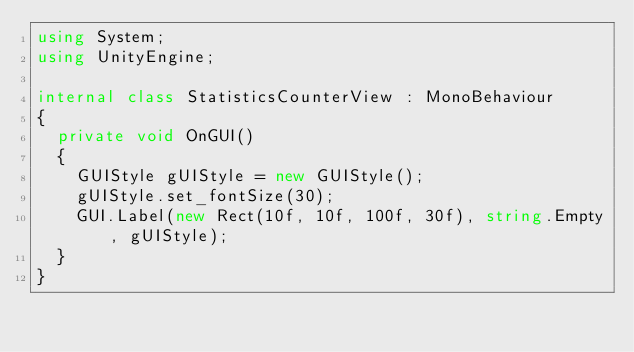<code> <loc_0><loc_0><loc_500><loc_500><_C#_>using System;
using UnityEngine;

internal class StatisticsCounterView : MonoBehaviour
{
	private void OnGUI()
	{
		GUIStyle gUIStyle = new GUIStyle();
		gUIStyle.set_fontSize(30);
		GUI.Label(new Rect(10f, 10f, 100f, 30f), string.Empty, gUIStyle);
	}
}
</code> 